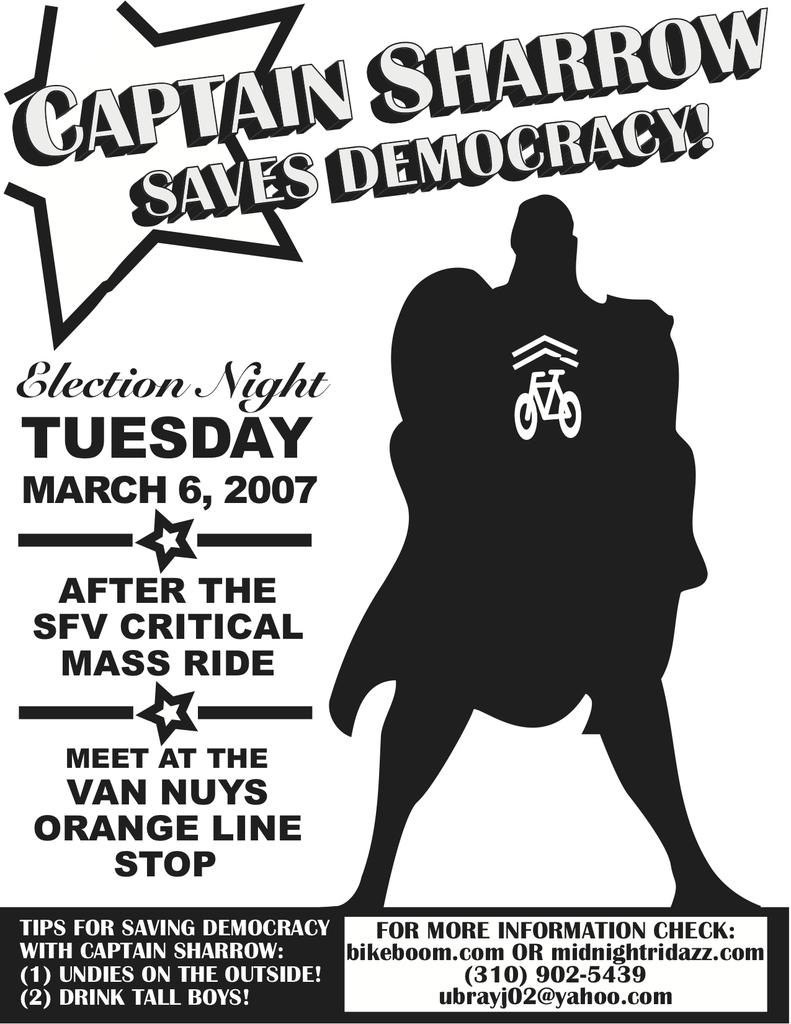How was the image altered or modified? The image is edited. What can be seen in the image besides the edited elements? There is a depiction of a person in the image. Where is the text located in the image? The text is on the left side of the image. What type of berry is being sold in the shop depicted in the image? There is no shop or berry present in the image; it features a person and edited elements. How many horses are pulling the carriage in the image? There is no carriage or horses present in the image. 